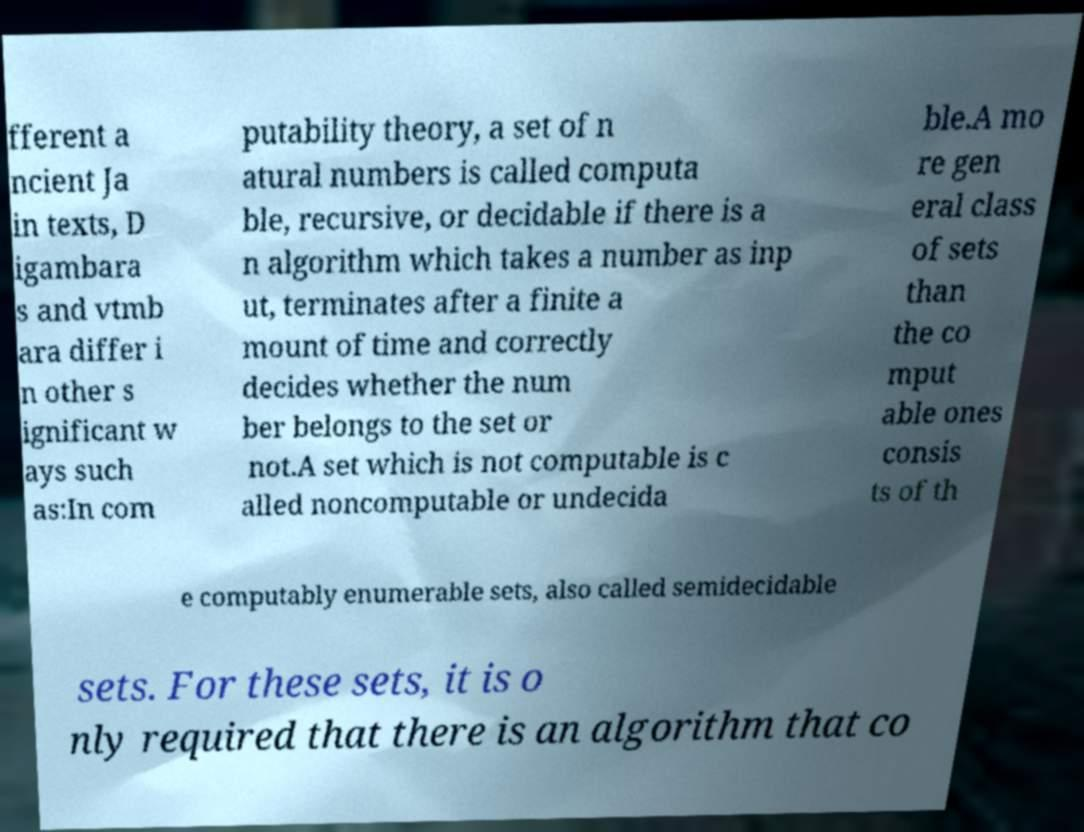Can you read and provide the text displayed in the image?This photo seems to have some interesting text. Can you extract and type it out for me? fferent a ncient Ja in texts, D igambara s and vtmb ara differ i n other s ignificant w ays such as:In com putability theory, a set of n atural numbers is called computa ble, recursive, or decidable if there is a n algorithm which takes a number as inp ut, terminates after a finite a mount of time and correctly decides whether the num ber belongs to the set or not.A set which is not computable is c alled noncomputable or undecida ble.A mo re gen eral class of sets than the co mput able ones consis ts of th e computably enumerable sets, also called semidecidable sets. For these sets, it is o nly required that there is an algorithm that co 